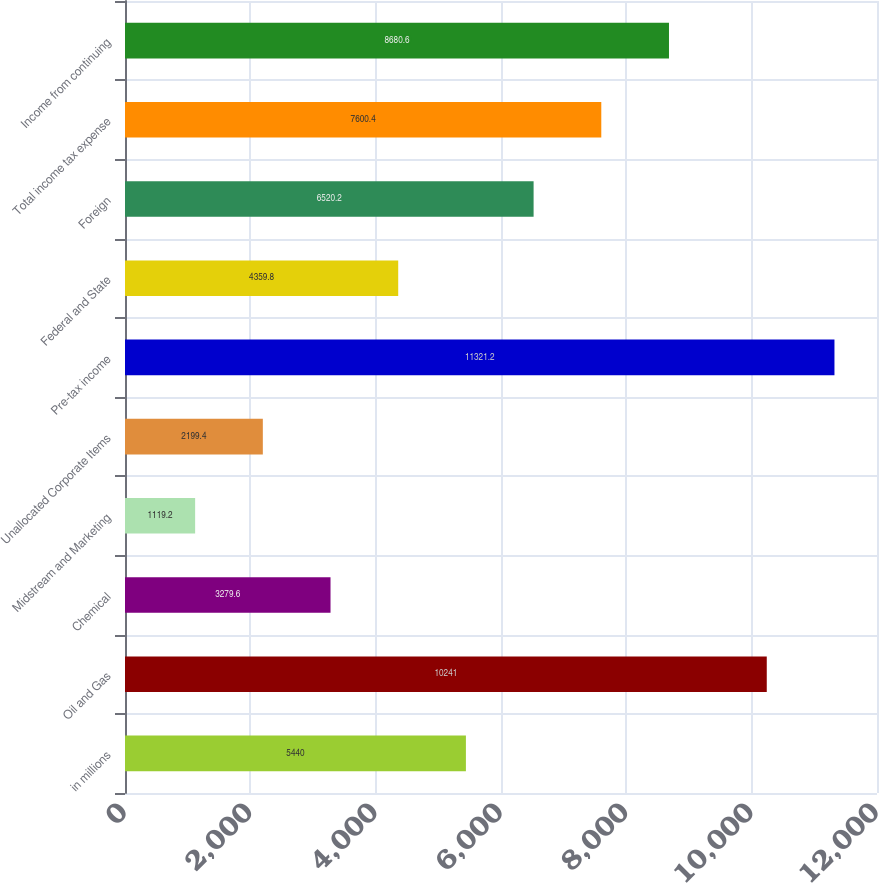Convert chart to OTSL. <chart><loc_0><loc_0><loc_500><loc_500><bar_chart><fcel>in millions<fcel>Oil and Gas<fcel>Chemical<fcel>Midstream and Marketing<fcel>Unallocated Corporate Items<fcel>Pre-tax income<fcel>Federal and State<fcel>Foreign<fcel>Total income tax expense<fcel>Income from continuing<nl><fcel>5440<fcel>10241<fcel>3279.6<fcel>1119.2<fcel>2199.4<fcel>11321.2<fcel>4359.8<fcel>6520.2<fcel>7600.4<fcel>8680.6<nl></chart> 